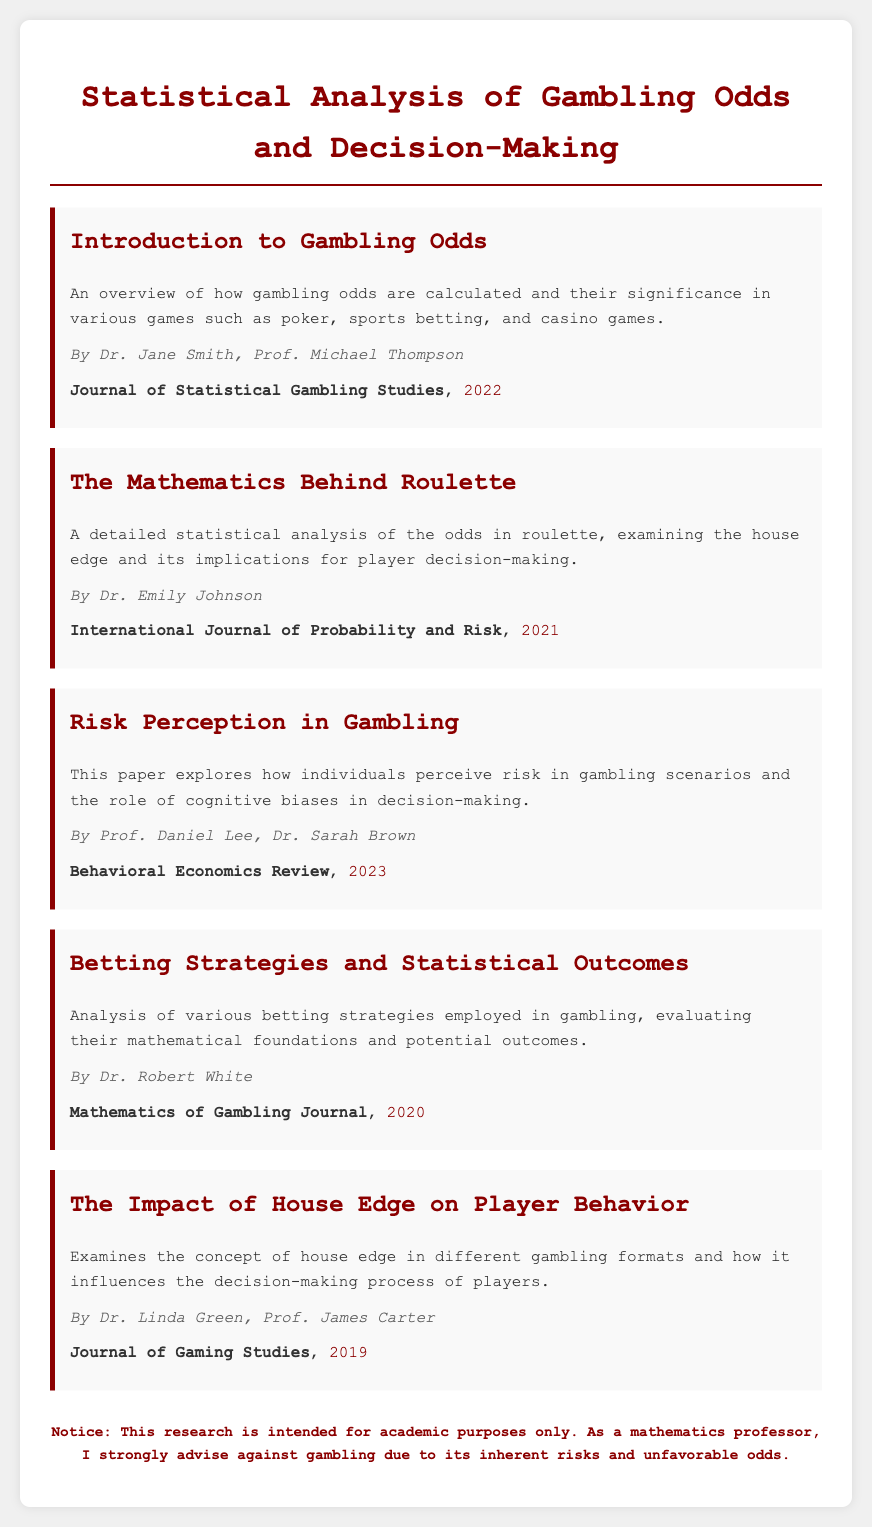What is the title of the document? The title is displayed prominently at the top of the document, indicating the main subject matter.
Answer: Statistical Analysis of Gambling Odds and Decision-Making Who authored the paper titled "Risk Perception in Gambling"? The authors of this specific paper are mentioned in the menu item providing details about it.
Answer: Prof. Daniel Lee, Dr. Sarah Brown In what year was the "Mathematics Behind Roulette" paper published? The year of publication is provided with the details of the corresponding paper in the document.
Answer: 2021 Which journal published the paper on "Betting Strategies and Statistical Outcomes"? The journal is specified in the publication details section of the menu item related to the paper.
Answer: Mathematics of Gambling Journal What is the main focus of the paper "The Impact of House Edge on Player Behavior"? The focus is summarized in the description below the title, indicating the subject matter investigated.
Answer: House edge and player decision-making Which author is associated with the "Introduction to Gambling Odds"? The authors for the introduction are listed directly below the title in the respective menu item.
Answer: Dr. Jane Smith, Prof. Michael Thompson What type of warning is included at the bottom of the document? The warning is presented distinctly to caution readers about gambling and its risks.
Answer: Academic purposes only What is the color of the title text? The color is defined in the style section and is evident in the rendered document.
Answer: Dark red 